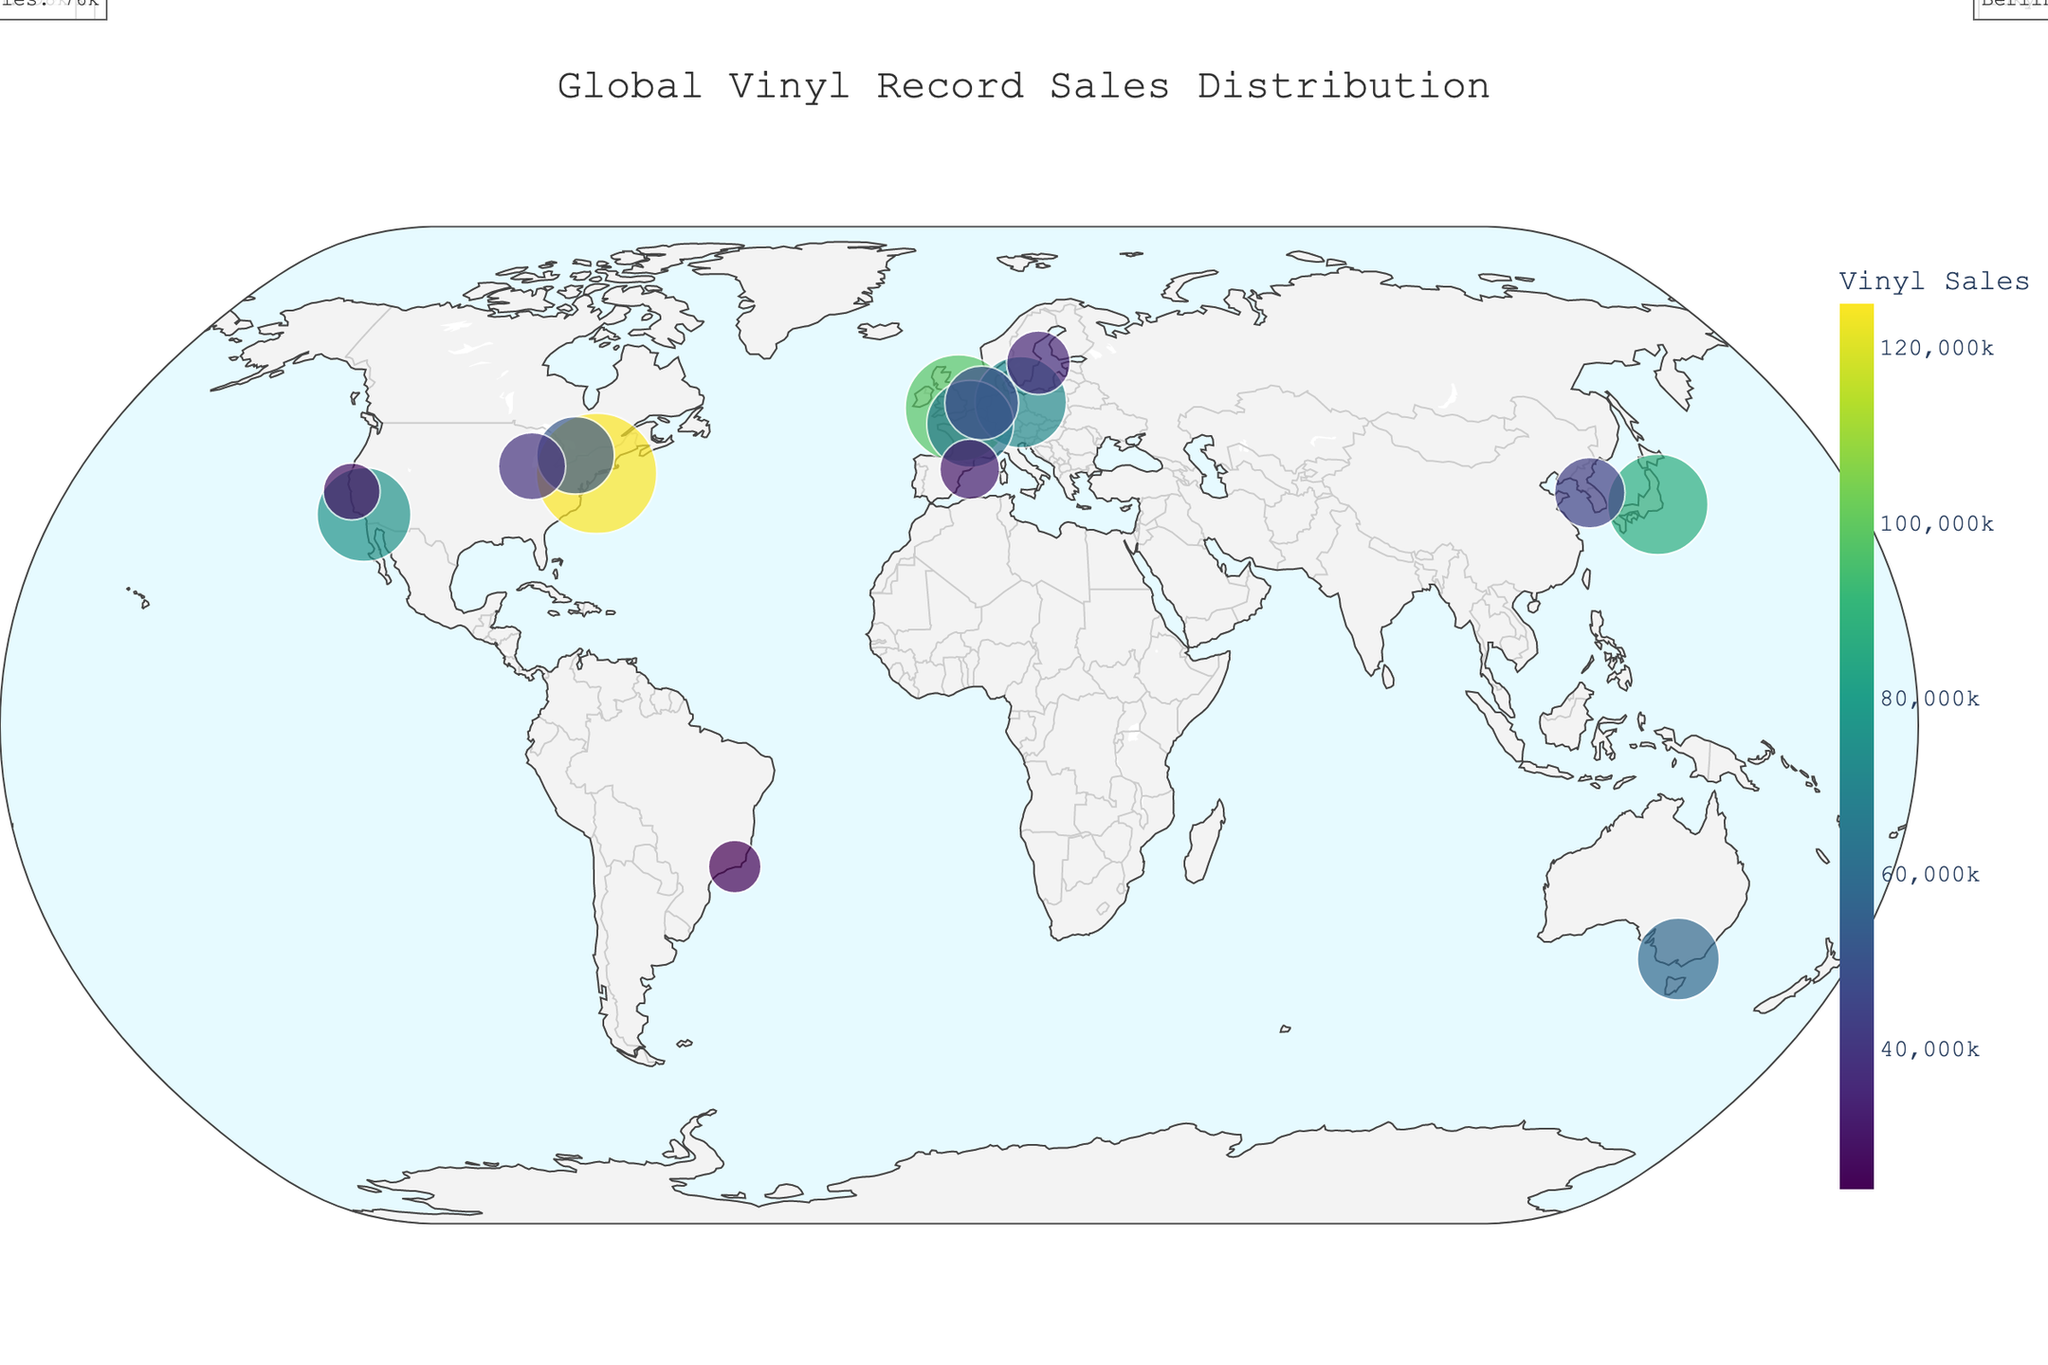Which city has the highest vinyl record sales? The title tells us the map shows vinyl record sales distribution worldwide, and the annotated labels distinguish New York as having the highest sales.
Answer: New York What is the total vinyl record sales for all cities combined? Summing up the vinyl sales from all cities: 125000 (New York) + 98000 (London) + 87000 (Tokyo) + 76000 (Los Angeles) + 72000 (Berlin) + 65000 (Paris) + 58000 (Melbourne) + 52000 (Toronto) + 47000 (Amsterdam) + 43000 (Seoul) + 39000 (Chicago) + 35000 (Stockholm) + 31000 (Barcelona) + 28000 (San Francisco) + 24000 (Rio de Janeiro) = 887000.
Answer: 887000 Which city in the USA has the second-highest sales of vinyl records? The annotated labels indicate New York, Los Angeles, Chicago, and San Francisco. Excluding New York, we see Los Angeles has the highest sales among the remaining cities.
Answer: Los Angeles How many cities have vinyl record sales over 50,000 units? Observing the annotated sales figures, the cities with over 50,000 units are New York, London, Tokyo, Los Angeles, Berlin, Paris, and Melbourne. Count these for a total.
Answer: 7 Which city is located at the highest latitude? By observing the positions of the cities along the latitudinal lines, we notice that Stockholm is the northernmost city on the map.
Answer: Stockholm Compare vinyl record sales between Berlin and Paris. Which city has higher sales, and by how much? Checking the annotated labels reveals Berlin has 72,000 sales, and Paris has 65,000. Subtract Paris' sales from Berlin's sales.
Answer: Berlin by 7000 Among the cities listed, which one is the southernmost? From examining the positions of the cities along the latitudinal lines, Melbourne appears to be the farthest south.
Answer: Melbourne What proportion of total vinyl record sales does Tokyo account for? First, find the combined total sales (887,000 from above), then calculate Tokyo's proportion. Tokyo's sales are 87,000. Divide 87,000 by 887,000 and convert to a percentage.
Answer: 9.8% What is the average vinyl record sales across all cities? Adding up all the sales figures and dividing by the number of cities: 887,000 total sales divided by 15 cities.
Answer: 59133 